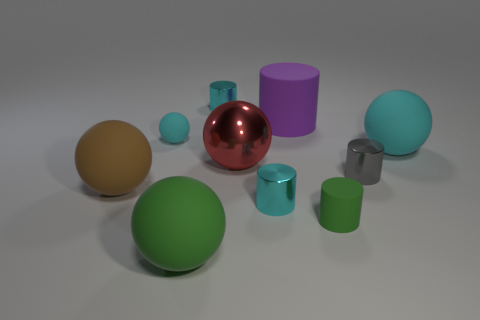Is the size of the brown ball the same as the purple matte cylinder? The sizes of the brown ball and the purple matte cylinder appear quite similar in the image; however, without exact measurements, it’s difficult to confirm if they are precisely the same size. They belong to a group of various geometric shapes and distinct colors, all of which have different sizes and provide a captivating visual comparison. 